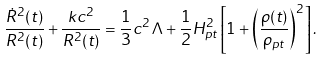Convert formula to latex. <formula><loc_0><loc_0><loc_500><loc_500>\frac { { \dot { R } } ^ { 2 } ( t ) } { R ^ { 2 } ( t ) } + \frac { k c ^ { 2 } } { R ^ { 2 } ( t ) } = \frac { 1 } { 3 } c ^ { 2 } \Lambda + \frac { 1 } { 2 } H _ { p t } ^ { 2 } \left [ 1 + \left ( \frac { \rho ( t ) } { \rho _ { p t } } \right ) ^ { 2 } \right ] .</formula> 